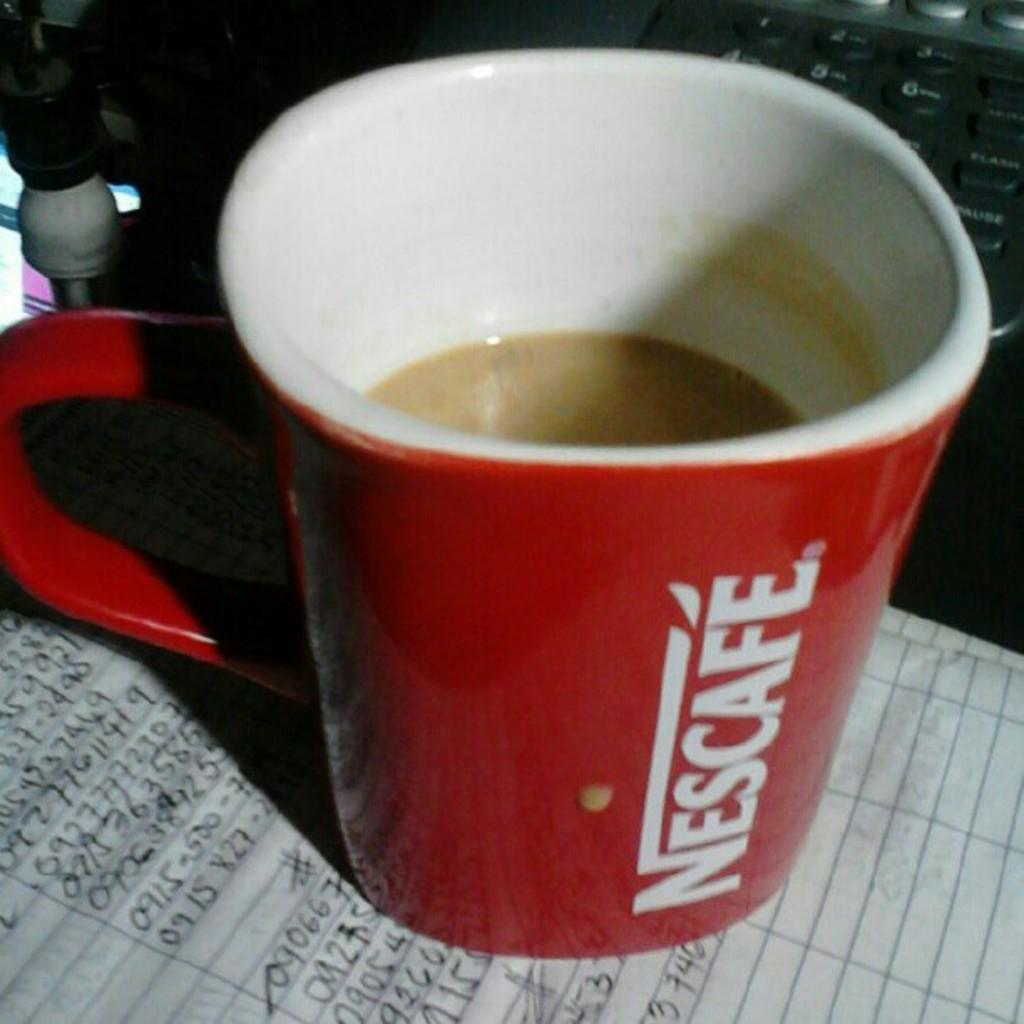<image>
Provide a brief description of the given image. A red coffee cup with Nescafe written on the side on top of piece paper with written numbers. 